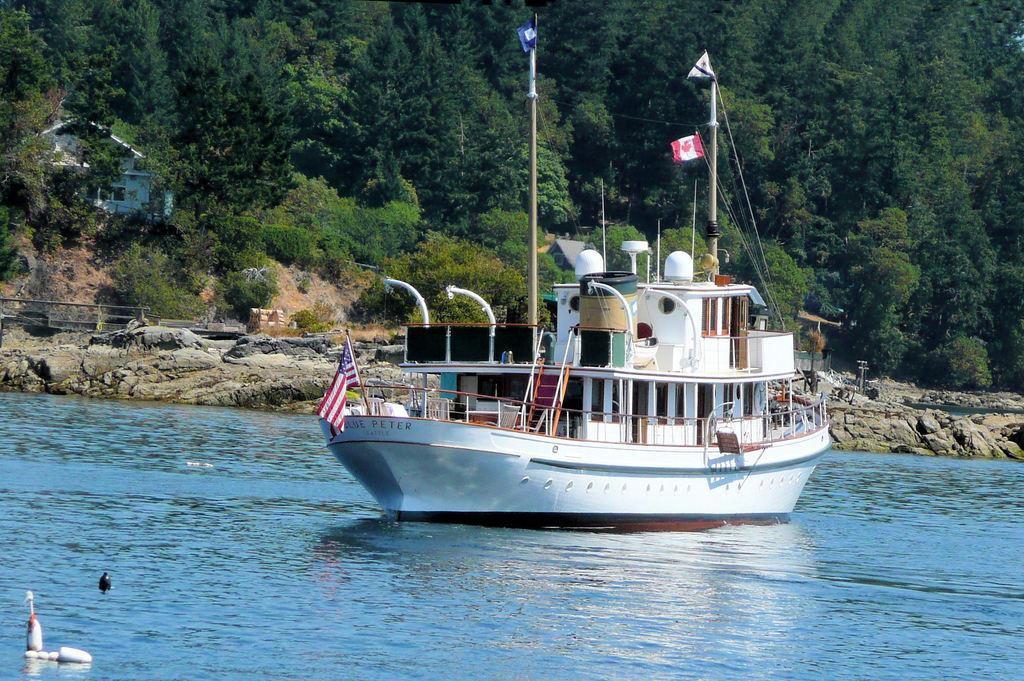<image>
Render a clear and concise summary of the photo. The Canadian ship has the name of Peter 